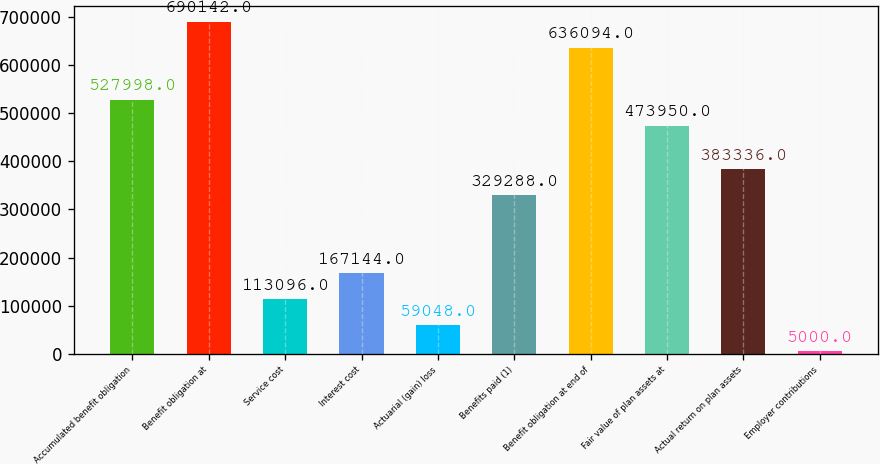Convert chart. <chart><loc_0><loc_0><loc_500><loc_500><bar_chart><fcel>Accumulated benefit obligation<fcel>Benefit obligation at<fcel>Service cost<fcel>Interest cost<fcel>Actuarial (gain) loss<fcel>Benefits paid (1)<fcel>Benefit obligation at end of<fcel>Fair value of plan assets at<fcel>Actual return on plan assets<fcel>Employer contributions<nl><fcel>527998<fcel>690142<fcel>113096<fcel>167144<fcel>59048<fcel>329288<fcel>636094<fcel>473950<fcel>383336<fcel>5000<nl></chart> 